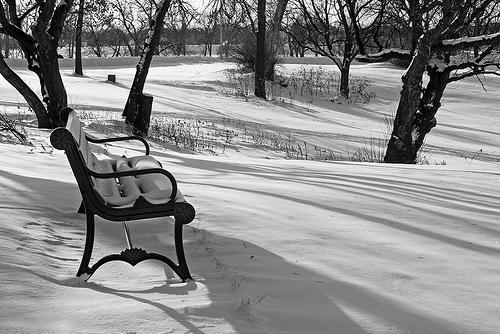How many benches?
Give a very brief answer. 1. How many arm rests on bench?
Give a very brief answer. 2. 